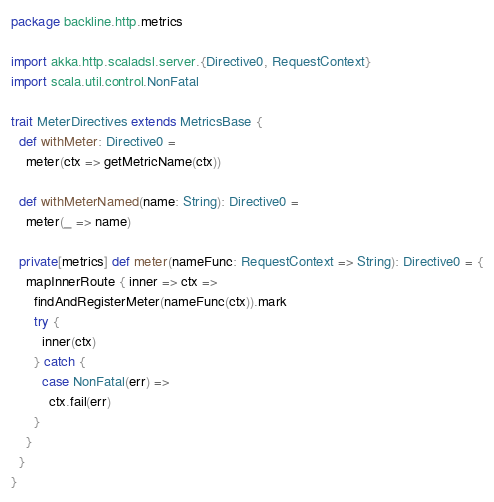Convert code to text. <code><loc_0><loc_0><loc_500><loc_500><_Scala_>package backline.http.metrics

import akka.http.scaladsl.server.{Directive0, RequestContext}
import scala.util.control.NonFatal

trait MeterDirectives extends MetricsBase {
  def withMeter: Directive0 =
    meter(ctx => getMetricName(ctx))

  def withMeterNamed(name: String): Directive0 =
    meter(_ => name)

  private[metrics] def meter(nameFunc: RequestContext => String): Directive0 = {
    mapInnerRoute { inner => ctx =>
      findAndRegisterMeter(nameFunc(ctx)).mark
      try {
        inner(ctx)
      } catch {
        case NonFatal(err) =>
          ctx.fail(err)
      }
    }
  }
}
</code> 